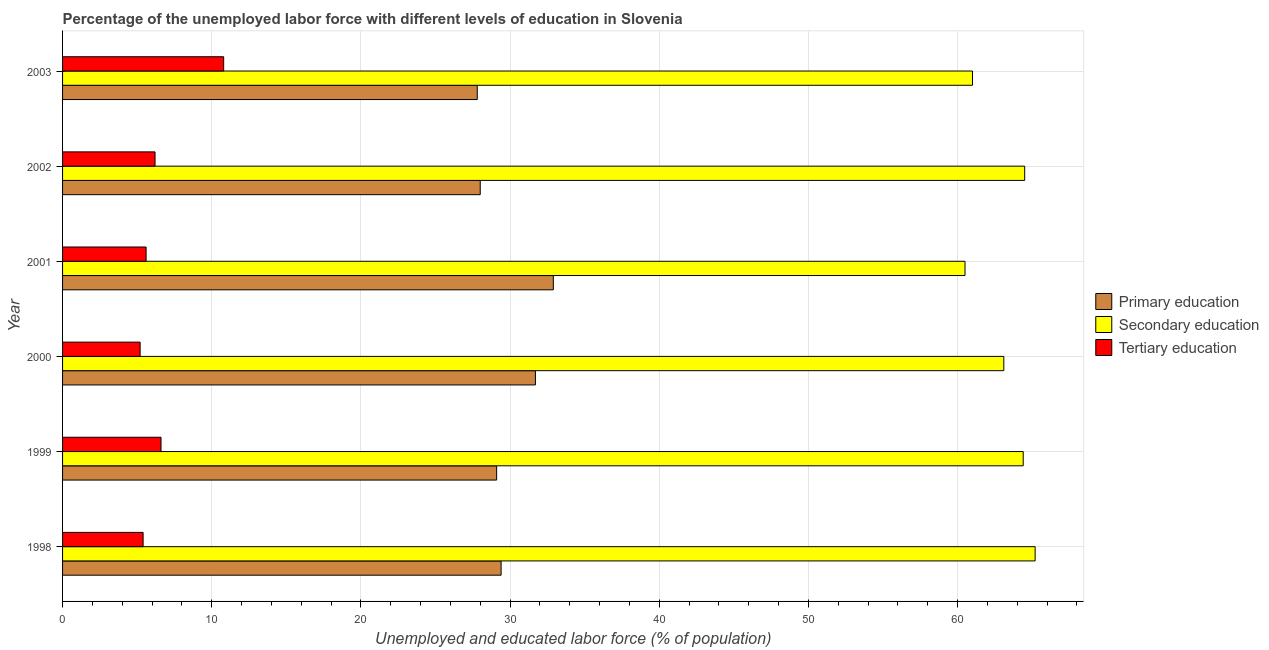Are the number of bars on each tick of the Y-axis equal?
Your answer should be very brief. Yes. How many bars are there on the 4th tick from the top?
Ensure brevity in your answer.  3. How many bars are there on the 6th tick from the bottom?
Your response must be concise. 3. In how many cases, is the number of bars for a given year not equal to the number of legend labels?
Your answer should be compact. 0. What is the percentage of labor force who received secondary education in 2002?
Ensure brevity in your answer.  64.5. Across all years, what is the maximum percentage of labor force who received tertiary education?
Make the answer very short. 10.8. Across all years, what is the minimum percentage of labor force who received primary education?
Your answer should be compact. 27.8. What is the total percentage of labor force who received tertiary education in the graph?
Offer a terse response. 39.8. What is the difference between the percentage of labor force who received secondary education in 2000 and that in 2001?
Provide a succinct answer. 2.6. What is the difference between the percentage of labor force who received primary education in 2001 and the percentage of labor force who received secondary education in 1998?
Provide a short and direct response. -32.3. What is the average percentage of labor force who received secondary education per year?
Provide a short and direct response. 63.12. In the year 2003, what is the difference between the percentage of labor force who received tertiary education and percentage of labor force who received secondary education?
Provide a succinct answer. -50.2. What is the ratio of the percentage of labor force who received tertiary education in 2001 to that in 2003?
Your answer should be very brief. 0.52. Is the difference between the percentage of labor force who received secondary education in 1998 and 2000 greater than the difference between the percentage of labor force who received tertiary education in 1998 and 2000?
Offer a terse response. Yes. What is the difference between the highest and the lowest percentage of labor force who received tertiary education?
Provide a succinct answer. 5.6. What does the 1st bar from the top in 1998 represents?
Ensure brevity in your answer.  Tertiary education. What does the 3rd bar from the bottom in 2000 represents?
Your answer should be very brief. Tertiary education. Is it the case that in every year, the sum of the percentage of labor force who received primary education and percentage of labor force who received secondary education is greater than the percentage of labor force who received tertiary education?
Give a very brief answer. Yes. Are all the bars in the graph horizontal?
Make the answer very short. Yes. What is the difference between two consecutive major ticks on the X-axis?
Provide a succinct answer. 10. Does the graph contain any zero values?
Offer a very short reply. No. Does the graph contain grids?
Provide a succinct answer. Yes. How are the legend labels stacked?
Your response must be concise. Vertical. What is the title of the graph?
Your response must be concise. Percentage of the unemployed labor force with different levels of education in Slovenia. Does "Agriculture" appear as one of the legend labels in the graph?
Provide a short and direct response. No. What is the label or title of the X-axis?
Provide a succinct answer. Unemployed and educated labor force (% of population). What is the label or title of the Y-axis?
Provide a succinct answer. Year. What is the Unemployed and educated labor force (% of population) in Primary education in 1998?
Your response must be concise. 29.4. What is the Unemployed and educated labor force (% of population) in Secondary education in 1998?
Give a very brief answer. 65.2. What is the Unemployed and educated labor force (% of population) of Tertiary education in 1998?
Your answer should be compact. 5.4. What is the Unemployed and educated labor force (% of population) of Primary education in 1999?
Provide a succinct answer. 29.1. What is the Unemployed and educated labor force (% of population) in Secondary education in 1999?
Ensure brevity in your answer.  64.4. What is the Unemployed and educated labor force (% of population) in Tertiary education in 1999?
Ensure brevity in your answer.  6.6. What is the Unemployed and educated labor force (% of population) of Primary education in 2000?
Offer a terse response. 31.7. What is the Unemployed and educated labor force (% of population) of Secondary education in 2000?
Make the answer very short. 63.1. What is the Unemployed and educated labor force (% of population) in Tertiary education in 2000?
Make the answer very short. 5.2. What is the Unemployed and educated labor force (% of population) of Primary education in 2001?
Your response must be concise. 32.9. What is the Unemployed and educated labor force (% of population) of Secondary education in 2001?
Your response must be concise. 60.5. What is the Unemployed and educated labor force (% of population) of Tertiary education in 2001?
Give a very brief answer. 5.6. What is the Unemployed and educated labor force (% of population) in Secondary education in 2002?
Offer a very short reply. 64.5. What is the Unemployed and educated labor force (% of population) of Tertiary education in 2002?
Ensure brevity in your answer.  6.2. What is the Unemployed and educated labor force (% of population) in Primary education in 2003?
Your answer should be very brief. 27.8. What is the Unemployed and educated labor force (% of population) of Tertiary education in 2003?
Offer a very short reply. 10.8. Across all years, what is the maximum Unemployed and educated labor force (% of population) of Primary education?
Your answer should be compact. 32.9. Across all years, what is the maximum Unemployed and educated labor force (% of population) of Secondary education?
Your response must be concise. 65.2. Across all years, what is the maximum Unemployed and educated labor force (% of population) of Tertiary education?
Your answer should be very brief. 10.8. Across all years, what is the minimum Unemployed and educated labor force (% of population) in Primary education?
Your response must be concise. 27.8. Across all years, what is the minimum Unemployed and educated labor force (% of population) of Secondary education?
Your response must be concise. 60.5. Across all years, what is the minimum Unemployed and educated labor force (% of population) in Tertiary education?
Your response must be concise. 5.2. What is the total Unemployed and educated labor force (% of population) in Primary education in the graph?
Your answer should be very brief. 178.9. What is the total Unemployed and educated labor force (% of population) of Secondary education in the graph?
Your response must be concise. 378.7. What is the total Unemployed and educated labor force (% of population) in Tertiary education in the graph?
Offer a very short reply. 39.8. What is the difference between the Unemployed and educated labor force (% of population) in Secondary education in 1998 and that in 1999?
Ensure brevity in your answer.  0.8. What is the difference between the Unemployed and educated labor force (% of population) in Primary education in 1998 and that in 2000?
Your answer should be compact. -2.3. What is the difference between the Unemployed and educated labor force (% of population) of Tertiary education in 1998 and that in 2000?
Offer a very short reply. 0.2. What is the difference between the Unemployed and educated labor force (% of population) in Primary education in 1998 and that in 2002?
Make the answer very short. 1.4. What is the difference between the Unemployed and educated labor force (% of population) of Secondary education in 1998 and that in 2002?
Offer a very short reply. 0.7. What is the difference between the Unemployed and educated labor force (% of population) of Tertiary education in 1998 and that in 2002?
Give a very brief answer. -0.8. What is the difference between the Unemployed and educated labor force (% of population) of Secondary education in 1998 and that in 2003?
Give a very brief answer. 4.2. What is the difference between the Unemployed and educated labor force (% of population) in Primary education in 1999 and that in 2001?
Offer a terse response. -3.8. What is the difference between the Unemployed and educated labor force (% of population) in Tertiary education in 1999 and that in 2003?
Your answer should be compact. -4.2. What is the difference between the Unemployed and educated labor force (% of population) of Tertiary education in 2000 and that in 2001?
Offer a very short reply. -0.4. What is the difference between the Unemployed and educated labor force (% of population) of Tertiary education in 2000 and that in 2003?
Ensure brevity in your answer.  -5.6. What is the difference between the Unemployed and educated labor force (% of population) of Secondary education in 2001 and that in 2002?
Make the answer very short. -4. What is the difference between the Unemployed and educated labor force (% of population) in Tertiary education in 2001 and that in 2003?
Your answer should be very brief. -5.2. What is the difference between the Unemployed and educated labor force (% of population) in Primary education in 2002 and that in 2003?
Offer a terse response. 0.2. What is the difference between the Unemployed and educated labor force (% of population) of Secondary education in 2002 and that in 2003?
Provide a succinct answer. 3.5. What is the difference between the Unemployed and educated labor force (% of population) in Tertiary education in 2002 and that in 2003?
Make the answer very short. -4.6. What is the difference between the Unemployed and educated labor force (% of population) in Primary education in 1998 and the Unemployed and educated labor force (% of population) in Secondary education in 1999?
Your answer should be very brief. -35. What is the difference between the Unemployed and educated labor force (% of population) of Primary education in 1998 and the Unemployed and educated labor force (% of population) of Tertiary education in 1999?
Your response must be concise. 22.8. What is the difference between the Unemployed and educated labor force (% of population) of Secondary education in 1998 and the Unemployed and educated labor force (% of population) of Tertiary education in 1999?
Your answer should be compact. 58.6. What is the difference between the Unemployed and educated labor force (% of population) in Primary education in 1998 and the Unemployed and educated labor force (% of population) in Secondary education in 2000?
Make the answer very short. -33.7. What is the difference between the Unemployed and educated labor force (% of population) of Primary education in 1998 and the Unemployed and educated labor force (% of population) of Tertiary education in 2000?
Keep it short and to the point. 24.2. What is the difference between the Unemployed and educated labor force (% of population) in Secondary education in 1998 and the Unemployed and educated labor force (% of population) in Tertiary education in 2000?
Your answer should be very brief. 60. What is the difference between the Unemployed and educated labor force (% of population) in Primary education in 1998 and the Unemployed and educated labor force (% of population) in Secondary education in 2001?
Your answer should be very brief. -31.1. What is the difference between the Unemployed and educated labor force (% of population) in Primary education in 1998 and the Unemployed and educated labor force (% of population) in Tertiary education in 2001?
Provide a succinct answer. 23.8. What is the difference between the Unemployed and educated labor force (% of population) in Secondary education in 1998 and the Unemployed and educated labor force (% of population) in Tertiary education in 2001?
Your response must be concise. 59.6. What is the difference between the Unemployed and educated labor force (% of population) in Primary education in 1998 and the Unemployed and educated labor force (% of population) in Secondary education in 2002?
Ensure brevity in your answer.  -35.1. What is the difference between the Unemployed and educated labor force (% of population) of Primary education in 1998 and the Unemployed and educated labor force (% of population) of Tertiary education in 2002?
Offer a very short reply. 23.2. What is the difference between the Unemployed and educated labor force (% of population) of Secondary education in 1998 and the Unemployed and educated labor force (% of population) of Tertiary education in 2002?
Provide a succinct answer. 59. What is the difference between the Unemployed and educated labor force (% of population) in Primary education in 1998 and the Unemployed and educated labor force (% of population) in Secondary education in 2003?
Your answer should be very brief. -31.6. What is the difference between the Unemployed and educated labor force (% of population) in Primary education in 1998 and the Unemployed and educated labor force (% of population) in Tertiary education in 2003?
Your answer should be very brief. 18.6. What is the difference between the Unemployed and educated labor force (% of population) of Secondary education in 1998 and the Unemployed and educated labor force (% of population) of Tertiary education in 2003?
Provide a succinct answer. 54.4. What is the difference between the Unemployed and educated labor force (% of population) of Primary education in 1999 and the Unemployed and educated labor force (% of population) of Secondary education in 2000?
Provide a succinct answer. -34. What is the difference between the Unemployed and educated labor force (% of population) in Primary education in 1999 and the Unemployed and educated labor force (% of population) in Tertiary education in 2000?
Give a very brief answer. 23.9. What is the difference between the Unemployed and educated labor force (% of population) in Secondary education in 1999 and the Unemployed and educated labor force (% of population) in Tertiary education in 2000?
Provide a short and direct response. 59.2. What is the difference between the Unemployed and educated labor force (% of population) in Primary education in 1999 and the Unemployed and educated labor force (% of population) in Secondary education in 2001?
Offer a very short reply. -31.4. What is the difference between the Unemployed and educated labor force (% of population) in Secondary education in 1999 and the Unemployed and educated labor force (% of population) in Tertiary education in 2001?
Your answer should be compact. 58.8. What is the difference between the Unemployed and educated labor force (% of population) in Primary education in 1999 and the Unemployed and educated labor force (% of population) in Secondary education in 2002?
Ensure brevity in your answer.  -35.4. What is the difference between the Unemployed and educated labor force (% of population) of Primary education in 1999 and the Unemployed and educated labor force (% of population) of Tertiary education in 2002?
Give a very brief answer. 22.9. What is the difference between the Unemployed and educated labor force (% of population) in Secondary education in 1999 and the Unemployed and educated labor force (% of population) in Tertiary education in 2002?
Keep it short and to the point. 58.2. What is the difference between the Unemployed and educated labor force (% of population) of Primary education in 1999 and the Unemployed and educated labor force (% of population) of Secondary education in 2003?
Offer a very short reply. -31.9. What is the difference between the Unemployed and educated labor force (% of population) in Secondary education in 1999 and the Unemployed and educated labor force (% of population) in Tertiary education in 2003?
Ensure brevity in your answer.  53.6. What is the difference between the Unemployed and educated labor force (% of population) of Primary education in 2000 and the Unemployed and educated labor force (% of population) of Secondary education in 2001?
Ensure brevity in your answer.  -28.8. What is the difference between the Unemployed and educated labor force (% of population) in Primary education in 2000 and the Unemployed and educated labor force (% of population) in Tertiary education in 2001?
Offer a very short reply. 26.1. What is the difference between the Unemployed and educated labor force (% of population) in Secondary education in 2000 and the Unemployed and educated labor force (% of population) in Tertiary education in 2001?
Provide a succinct answer. 57.5. What is the difference between the Unemployed and educated labor force (% of population) in Primary education in 2000 and the Unemployed and educated labor force (% of population) in Secondary education in 2002?
Ensure brevity in your answer.  -32.8. What is the difference between the Unemployed and educated labor force (% of population) in Secondary education in 2000 and the Unemployed and educated labor force (% of population) in Tertiary education in 2002?
Offer a terse response. 56.9. What is the difference between the Unemployed and educated labor force (% of population) in Primary education in 2000 and the Unemployed and educated labor force (% of population) in Secondary education in 2003?
Make the answer very short. -29.3. What is the difference between the Unemployed and educated labor force (% of population) in Primary education in 2000 and the Unemployed and educated labor force (% of population) in Tertiary education in 2003?
Your response must be concise. 20.9. What is the difference between the Unemployed and educated labor force (% of population) in Secondary education in 2000 and the Unemployed and educated labor force (% of population) in Tertiary education in 2003?
Keep it short and to the point. 52.3. What is the difference between the Unemployed and educated labor force (% of population) of Primary education in 2001 and the Unemployed and educated labor force (% of population) of Secondary education in 2002?
Offer a terse response. -31.6. What is the difference between the Unemployed and educated labor force (% of population) in Primary education in 2001 and the Unemployed and educated labor force (% of population) in Tertiary education in 2002?
Your answer should be very brief. 26.7. What is the difference between the Unemployed and educated labor force (% of population) in Secondary education in 2001 and the Unemployed and educated labor force (% of population) in Tertiary education in 2002?
Make the answer very short. 54.3. What is the difference between the Unemployed and educated labor force (% of population) in Primary education in 2001 and the Unemployed and educated labor force (% of population) in Secondary education in 2003?
Your answer should be very brief. -28.1. What is the difference between the Unemployed and educated labor force (% of population) of Primary education in 2001 and the Unemployed and educated labor force (% of population) of Tertiary education in 2003?
Provide a short and direct response. 22.1. What is the difference between the Unemployed and educated labor force (% of population) of Secondary education in 2001 and the Unemployed and educated labor force (% of population) of Tertiary education in 2003?
Provide a succinct answer. 49.7. What is the difference between the Unemployed and educated labor force (% of population) of Primary education in 2002 and the Unemployed and educated labor force (% of population) of Secondary education in 2003?
Keep it short and to the point. -33. What is the difference between the Unemployed and educated labor force (% of population) in Primary education in 2002 and the Unemployed and educated labor force (% of population) in Tertiary education in 2003?
Your answer should be very brief. 17.2. What is the difference between the Unemployed and educated labor force (% of population) of Secondary education in 2002 and the Unemployed and educated labor force (% of population) of Tertiary education in 2003?
Ensure brevity in your answer.  53.7. What is the average Unemployed and educated labor force (% of population) of Primary education per year?
Ensure brevity in your answer.  29.82. What is the average Unemployed and educated labor force (% of population) in Secondary education per year?
Give a very brief answer. 63.12. What is the average Unemployed and educated labor force (% of population) of Tertiary education per year?
Ensure brevity in your answer.  6.63. In the year 1998, what is the difference between the Unemployed and educated labor force (% of population) in Primary education and Unemployed and educated labor force (% of population) in Secondary education?
Make the answer very short. -35.8. In the year 1998, what is the difference between the Unemployed and educated labor force (% of population) of Primary education and Unemployed and educated labor force (% of population) of Tertiary education?
Provide a short and direct response. 24. In the year 1998, what is the difference between the Unemployed and educated labor force (% of population) in Secondary education and Unemployed and educated labor force (% of population) in Tertiary education?
Ensure brevity in your answer.  59.8. In the year 1999, what is the difference between the Unemployed and educated labor force (% of population) of Primary education and Unemployed and educated labor force (% of population) of Secondary education?
Offer a very short reply. -35.3. In the year 1999, what is the difference between the Unemployed and educated labor force (% of population) in Primary education and Unemployed and educated labor force (% of population) in Tertiary education?
Offer a very short reply. 22.5. In the year 1999, what is the difference between the Unemployed and educated labor force (% of population) of Secondary education and Unemployed and educated labor force (% of population) of Tertiary education?
Offer a terse response. 57.8. In the year 2000, what is the difference between the Unemployed and educated labor force (% of population) in Primary education and Unemployed and educated labor force (% of population) in Secondary education?
Provide a succinct answer. -31.4. In the year 2000, what is the difference between the Unemployed and educated labor force (% of population) of Primary education and Unemployed and educated labor force (% of population) of Tertiary education?
Your answer should be very brief. 26.5. In the year 2000, what is the difference between the Unemployed and educated labor force (% of population) of Secondary education and Unemployed and educated labor force (% of population) of Tertiary education?
Your answer should be compact. 57.9. In the year 2001, what is the difference between the Unemployed and educated labor force (% of population) in Primary education and Unemployed and educated labor force (% of population) in Secondary education?
Offer a terse response. -27.6. In the year 2001, what is the difference between the Unemployed and educated labor force (% of population) in Primary education and Unemployed and educated labor force (% of population) in Tertiary education?
Ensure brevity in your answer.  27.3. In the year 2001, what is the difference between the Unemployed and educated labor force (% of population) in Secondary education and Unemployed and educated labor force (% of population) in Tertiary education?
Provide a short and direct response. 54.9. In the year 2002, what is the difference between the Unemployed and educated labor force (% of population) of Primary education and Unemployed and educated labor force (% of population) of Secondary education?
Offer a very short reply. -36.5. In the year 2002, what is the difference between the Unemployed and educated labor force (% of population) of Primary education and Unemployed and educated labor force (% of population) of Tertiary education?
Provide a short and direct response. 21.8. In the year 2002, what is the difference between the Unemployed and educated labor force (% of population) of Secondary education and Unemployed and educated labor force (% of population) of Tertiary education?
Offer a terse response. 58.3. In the year 2003, what is the difference between the Unemployed and educated labor force (% of population) of Primary education and Unemployed and educated labor force (% of population) of Secondary education?
Your answer should be compact. -33.2. In the year 2003, what is the difference between the Unemployed and educated labor force (% of population) of Secondary education and Unemployed and educated labor force (% of population) of Tertiary education?
Make the answer very short. 50.2. What is the ratio of the Unemployed and educated labor force (% of population) in Primary education in 1998 to that in 1999?
Give a very brief answer. 1.01. What is the ratio of the Unemployed and educated labor force (% of population) of Secondary education in 1998 to that in 1999?
Keep it short and to the point. 1.01. What is the ratio of the Unemployed and educated labor force (% of population) of Tertiary education in 1998 to that in 1999?
Keep it short and to the point. 0.82. What is the ratio of the Unemployed and educated labor force (% of population) of Primary education in 1998 to that in 2000?
Give a very brief answer. 0.93. What is the ratio of the Unemployed and educated labor force (% of population) of Secondary education in 1998 to that in 2000?
Offer a very short reply. 1.03. What is the ratio of the Unemployed and educated labor force (% of population) of Primary education in 1998 to that in 2001?
Your response must be concise. 0.89. What is the ratio of the Unemployed and educated labor force (% of population) in Secondary education in 1998 to that in 2001?
Offer a very short reply. 1.08. What is the ratio of the Unemployed and educated labor force (% of population) of Primary education in 1998 to that in 2002?
Offer a very short reply. 1.05. What is the ratio of the Unemployed and educated labor force (% of population) in Secondary education in 1998 to that in 2002?
Your response must be concise. 1.01. What is the ratio of the Unemployed and educated labor force (% of population) of Tertiary education in 1998 to that in 2002?
Offer a very short reply. 0.87. What is the ratio of the Unemployed and educated labor force (% of population) of Primary education in 1998 to that in 2003?
Provide a short and direct response. 1.06. What is the ratio of the Unemployed and educated labor force (% of population) in Secondary education in 1998 to that in 2003?
Offer a terse response. 1.07. What is the ratio of the Unemployed and educated labor force (% of population) of Tertiary education in 1998 to that in 2003?
Ensure brevity in your answer.  0.5. What is the ratio of the Unemployed and educated labor force (% of population) in Primary education in 1999 to that in 2000?
Provide a short and direct response. 0.92. What is the ratio of the Unemployed and educated labor force (% of population) in Secondary education in 1999 to that in 2000?
Offer a terse response. 1.02. What is the ratio of the Unemployed and educated labor force (% of population) of Tertiary education in 1999 to that in 2000?
Provide a succinct answer. 1.27. What is the ratio of the Unemployed and educated labor force (% of population) in Primary education in 1999 to that in 2001?
Your answer should be very brief. 0.88. What is the ratio of the Unemployed and educated labor force (% of population) of Secondary education in 1999 to that in 2001?
Your answer should be very brief. 1.06. What is the ratio of the Unemployed and educated labor force (% of population) in Tertiary education in 1999 to that in 2001?
Your answer should be compact. 1.18. What is the ratio of the Unemployed and educated labor force (% of population) of Primary education in 1999 to that in 2002?
Offer a very short reply. 1.04. What is the ratio of the Unemployed and educated labor force (% of population) in Tertiary education in 1999 to that in 2002?
Make the answer very short. 1.06. What is the ratio of the Unemployed and educated labor force (% of population) in Primary education in 1999 to that in 2003?
Keep it short and to the point. 1.05. What is the ratio of the Unemployed and educated labor force (% of population) of Secondary education in 1999 to that in 2003?
Provide a succinct answer. 1.06. What is the ratio of the Unemployed and educated labor force (% of population) of Tertiary education in 1999 to that in 2003?
Give a very brief answer. 0.61. What is the ratio of the Unemployed and educated labor force (% of population) in Primary education in 2000 to that in 2001?
Provide a short and direct response. 0.96. What is the ratio of the Unemployed and educated labor force (% of population) of Secondary education in 2000 to that in 2001?
Offer a very short reply. 1.04. What is the ratio of the Unemployed and educated labor force (% of population) in Tertiary education in 2000 to that in 2001?
Offer a terse response. 0.93. What is the ratio of the Unemployed and educated labor force (% of population) of Primary education in 2000 to that in 2002?
Your answer should be very brief. 1.13. What is the ratio of the Unemployed and educated labor force (% of population) in Secondary education in 2000 to that in 2002?
Make the answer very short. 0.98. What is the ratio of the Unemployed and educated labor force (% of population) of Tertiary education in 2000 to that in 2002?
Provide a succinct answer. 0.84. What is the ratio of the Unemployed and educated labor force (% of population) in Primary education in 2000 to that in 2003?
Your response must be concise. 1.14. What is the ratio of the Unemployed and educated labor force (% of population) in Secondary education in 2000 to that in 2003?
Offer a very short reply. 1.03. What is the ratio of the Unemployed and educated labor force (% of population) in Tertiary education in 2000 to that in 2003?
Make the answer very short. 0.48. What is the ratio of the Unemployed and educated labor force (% of population) of Primary education in 2001 to that in 2002?
Ensure brevity in your answer.  1.18. What is the ratio of the Unemployed and educated labor force (% of population) of Secondary education in 2001 to that in 2002?
Your answer should be very brief. 0.94. What is the ratio of the Unemployed and educated labor force (% of population) of Tertiary education in 2001 to that in 2002?
Your answer should be very brief. 0.9. What is the ratio of the Unemployed and educated labor force (% of population) of Primary education in 2001 to that in 2003?
Offer a very short reply. 1.18. What is the ratio of the Unemployed and educated labor force (% of population) of Secondary education in 2001 to that in 2003?
Keep it short and to the point. 0.99. What is the ratio of the Unemployed and educated labor force (% of population) of Tertiary education in 2001 to that in 2003?
Keep it short and to the point. 0.52. What is the ratio of the Unemployed and educated labor force (% of population) of Primary education in 2002 to that in 2003?
Your response must be concise. 1.01. What is the ratio of the Unemployed and educated labor force (% of population) of Secondary education in 2002 to that in 2003?
Ensure brevity in your answer.  1.06. What is the ratio of the Unemployed and educated labor force (% of population) of Tertiary education in 2002 to that in 2003?
Provide a short and direct response. 0.57. What is the difference between the highest and the second highest Unemployed and educated labor force (% of population) of Primary education?
Offer a very short reply. 1.2. What is the difference between the highest and the second highest Unemployed and educated labor force (% of population) in Secondary education?
Keep it short and to the point. 0.7. What is the difference between the highest and the lowest Unemployed and educated labor force (% of population) in Secondary education?
Make the answer very short. 4.7. 